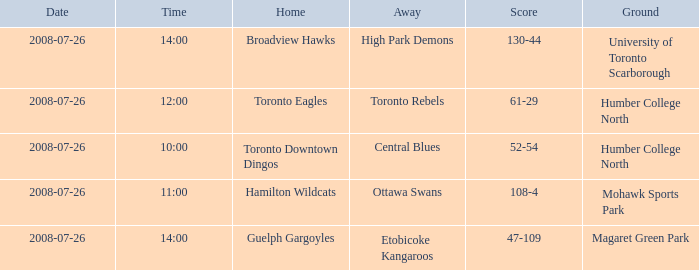Could you help me parse every detail presented in this table? {'header': ['Date', 'Time', 'Home', 'Away', 'Score', 'Ground'], 'rows': [['2008-07-26', '14:00', 'Broadview Hawks', 'High Park Demons', '130-44', 'University of Toronto Scarborough'], ['2008-07-26', '12:00', 'Toronto Eagles', 'Toronto Rebels', '61-29', 'Humber College North'], ['2008-07-26', '10:00', 'Toronto Downtown Dingos', 'Central Blues', '52-54', 'Humber College North'], ['2008-07-26', '11:00', 'Hamilton Wildcats', 'Ottawa Swans', '108-4', 'Mohawk Sports Park'], ['2008-07-26', '14:00', 'Guelph Gargoyles', 'Etobicoke Kangaroos', '47-109', 'Magaret Green Park']]} When did the High Park Demons play Away? 2008-07-26. 